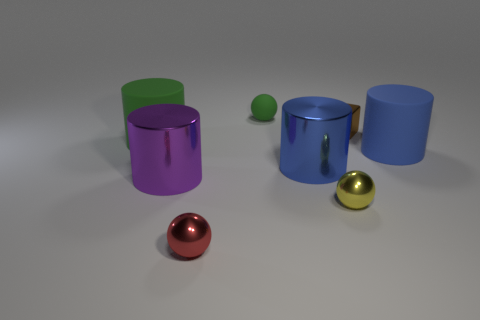Are there any other things that are the same shape as the tiny brown shiny thing?
Your response must be concise. No. What shape is the yellow object?
Your answer should be very brief. Sphere. Are there any other things that have the same color as the small rubber ball?
Offer a terse response. Yes. Is the size of the green matte object that is to the left of the red shiny ball the same as the matte cylinder that is in front of the big green cylinder?
Your response must be concise. Yes. The tiny yellow thing that is in front of the small green matte object behind the blue matte thing is what shape?
Ensure brevity in your answer.  Sphere. Do the yellow shiny object and the blue object behind the large blue metallic object have the same size?
Make the answer very short. No. There is a green matte thing left of the small shiny object that is to the left of the metallic sphere that is on the right side of the small red object; what size is it?
Your answer should be very brief. Large. What number of things are big objects on the right side of the large purple object or red objects?
Your response must be concise. 3. How many big green things are behind the big matte cylinder that is left of the tiny green object?
Make the answer very short. 0. Are there more cubes in front of the tiny green thing than small gray metallic cylinders?
Provide a succinct answer. Yes. 